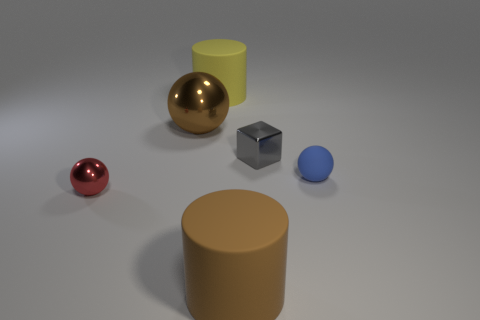Does the matte cylinder that is in front of the small red object have the same size as the brown object behind the small red sphere?
Ensure brevity in your answer.  Yes. The big matte cylinder that is in front of the big object left of the large yellow cylinder is what color?
Give a very brief answer. Brown. What material is the brown cylinder that is the same size as the yellow rubber cylinder?
Offer a terse response. Rubber. How many matte things are either big cylinders or cyan things?
Offer a terse response. 2. What color is the matte object that is both behind the small red object and in front of the yellow cylinder?
Give a very brief answer. Blue. How many balls are on the right side of the large sphere?
Ensure brevity in your answer.  1. What is the small blue thing made of?
Offer a very short reply. Rubber. What is the color of the tiny object left of the cylinder behind the tiny shiny thing in front of the blue ball?
Ensure brevity in your answer.  Red. What number of objects have the same size as the blue sphere?
Offer a very short reply. 2. What is the color of the cylinder in front of the tiny matte thing?
Offer a very short reply. Brown. 